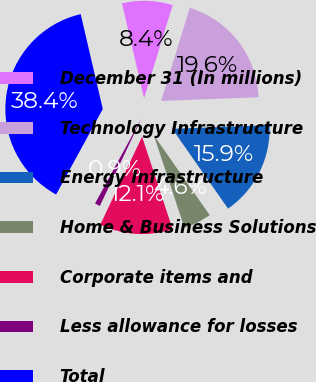Convert chart. <chart><loc_0><loc_0><loc_500><loc_500><pie_chart><fcel>December 31 (In millions)<fcel>Technology Infrastructure<fcel>Energy Infrastructure<fcel>Home & Business Solutions<fcel>Corporate items and<fcel>Less allowance for losses<fcel>Total<nl><fcel>8.39%<fcel>19.65%<fcel>15.89%<fcel>4.64%<fcel>12.14%<fcel>0.88%<fcel>38.41%<nl></chart> 